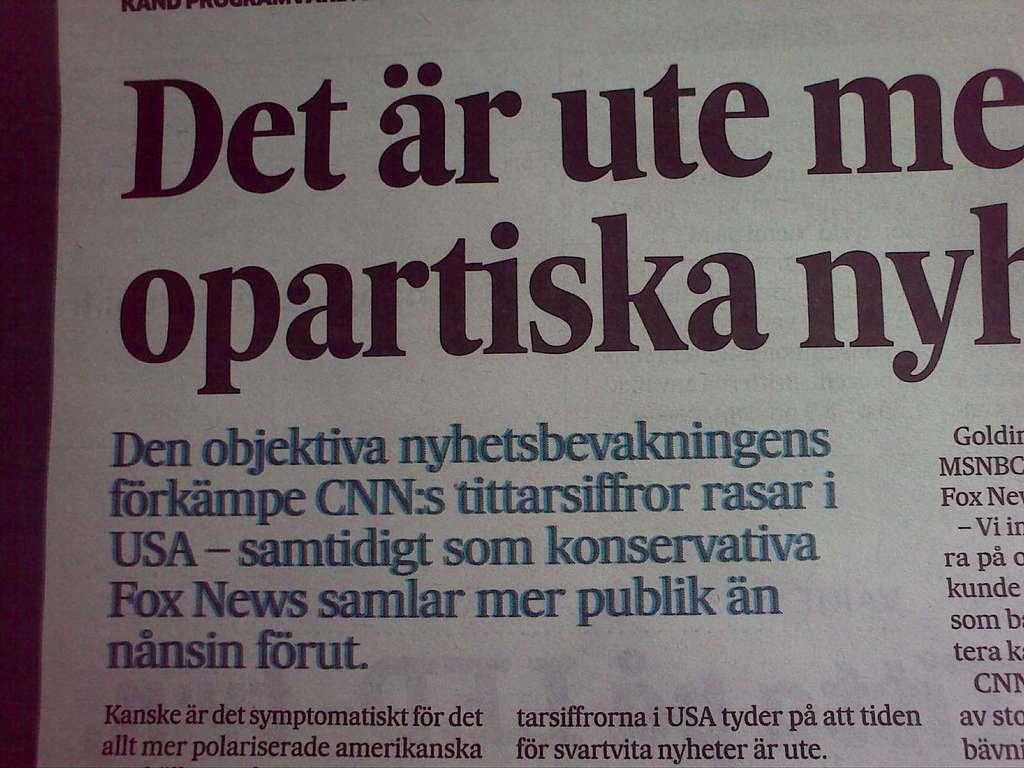<image>
Render a clear and concise summary of the photo. A newspaper article with a title beginning Det ar ute. 